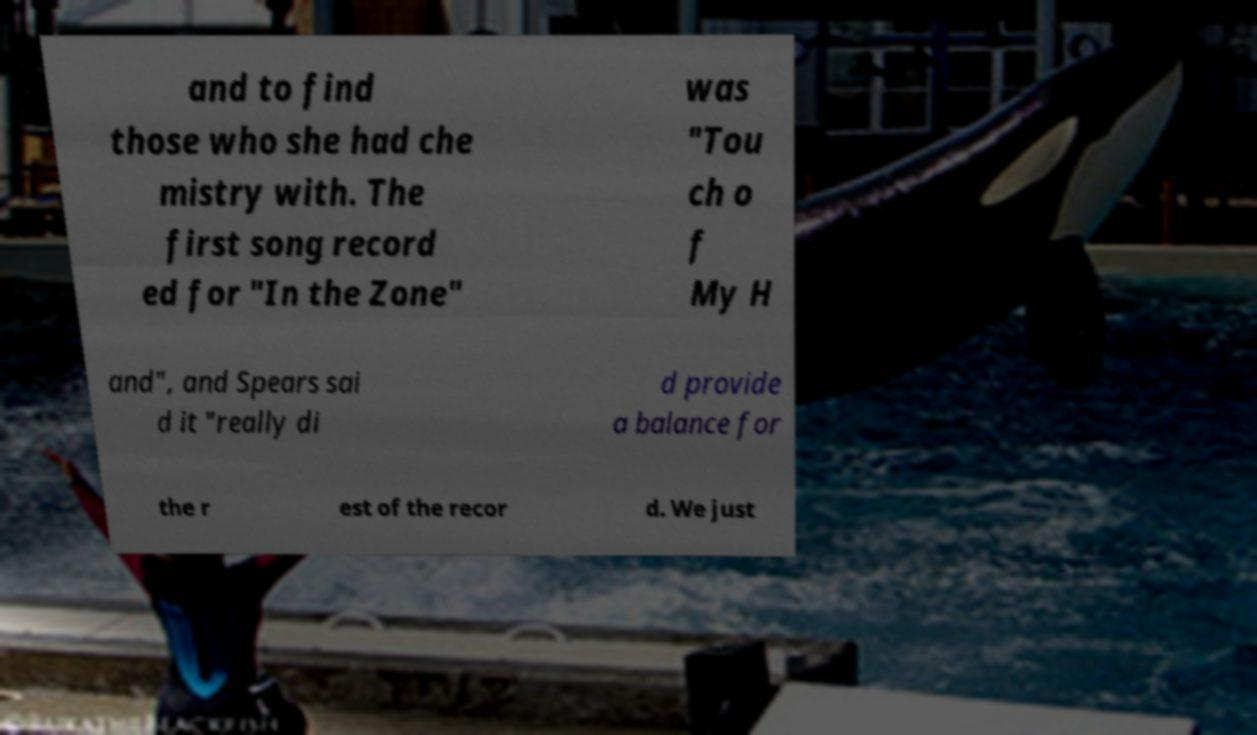There's text embedded in this image that I need extracted. Can you transcribe it verbatim? and to find those who she had che mistry with. The first song record ed for "In the Zone" was "Tou ch o f My H and", and Spears sai d it "really di d provide a balance for the r est of the recor d. We just 